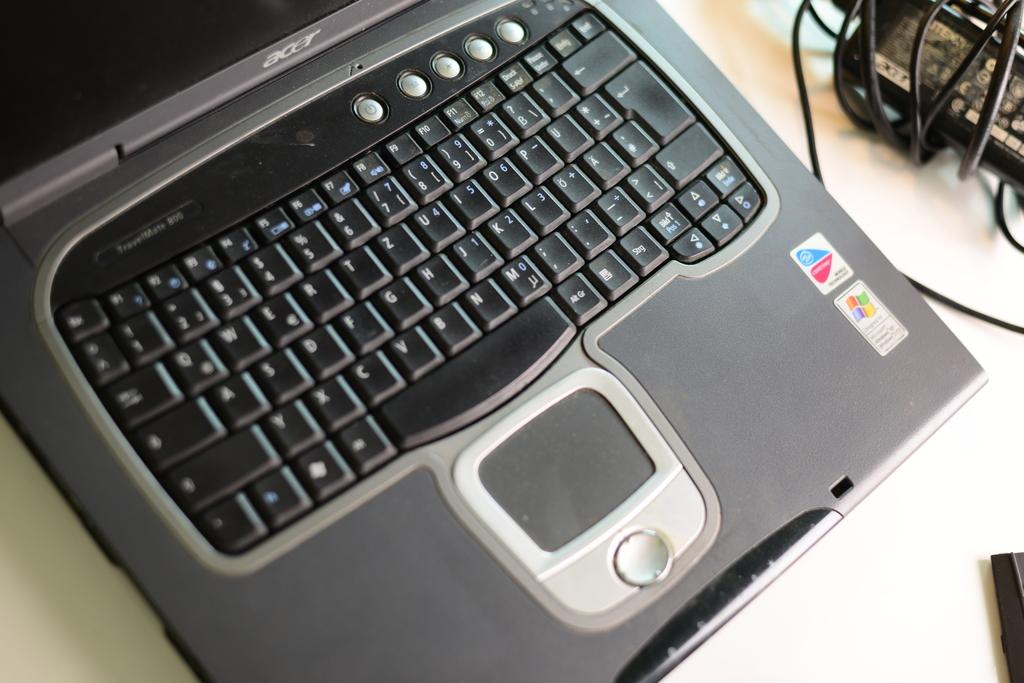What brand is this laptop?
Offer a terse response. Acer. 